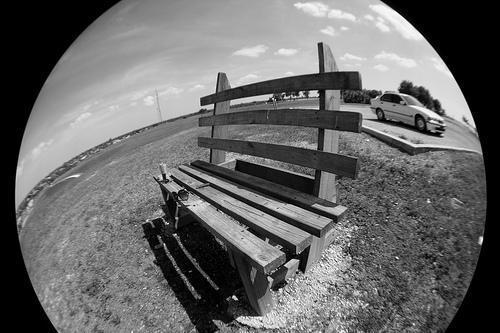How many benches are there?
Give a very brief answer. 1. 